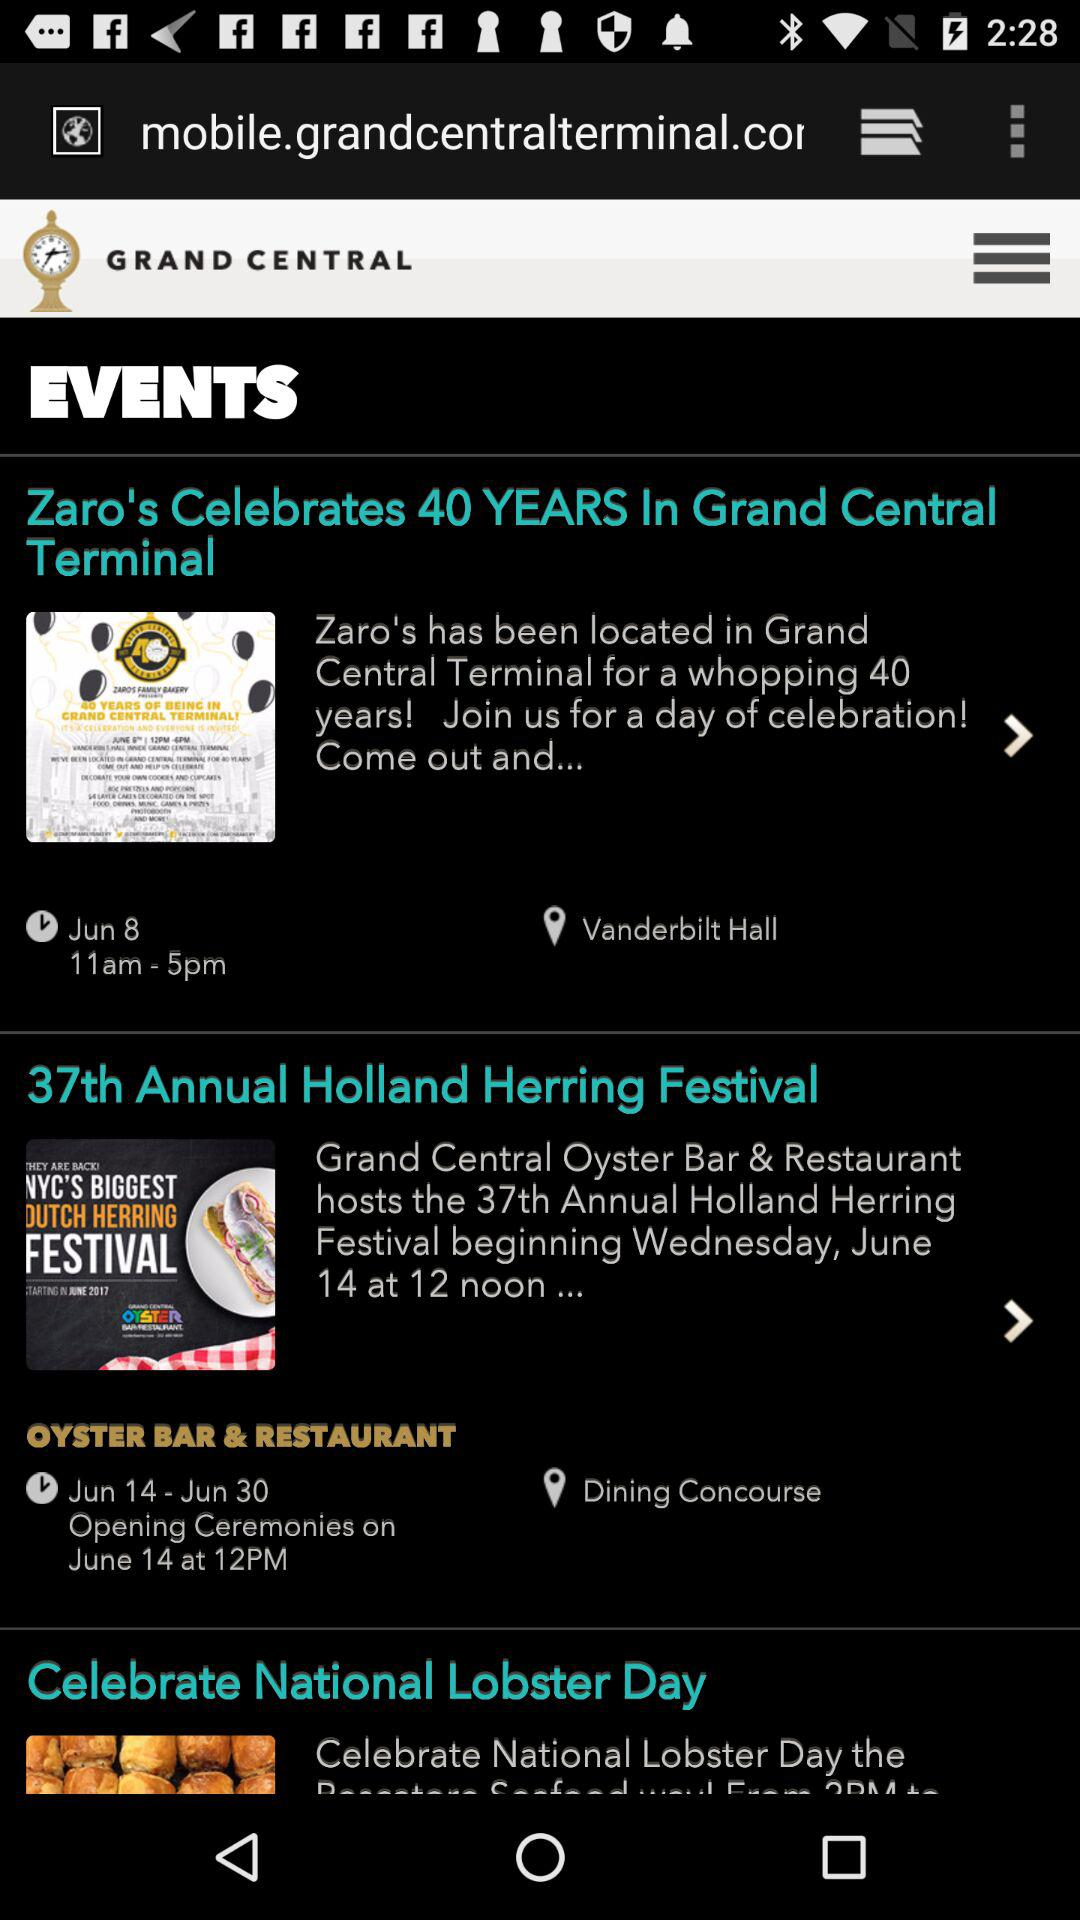What is the date of Zaro's celebration of 40 years? The date is June 8. 